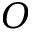Convert formula to latex. <formula><loc_0><loc_0><loc_500><loc_500>O</formula> 